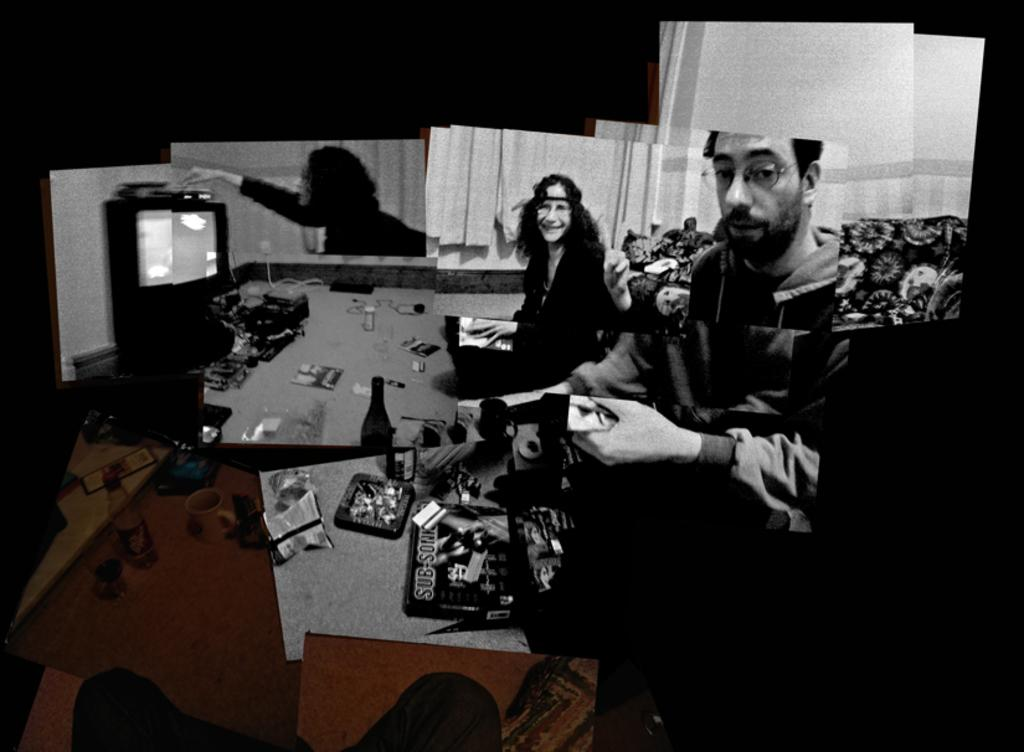What can be seen in the image? There are people, bottles, a cup, a glass, a chips packet, and a television in the image. What type of containers are present in the image? There are bottles, a cup, and a glass in the image. What type of snack is visible in the image? There is a chips packet in the image. What is the background of the image like? The background of the image is dark. Where is the glue being used in the image? There is no glue present in the image. What type of pan can be seen on the table in the image? There is no pan present in the image. 